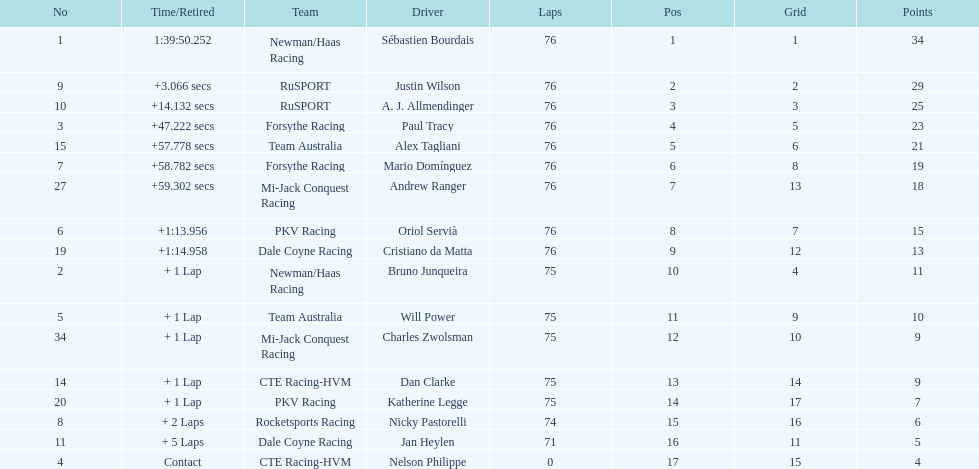Could you parse the entire table as a dict? {'header': ['No', 'Time/Retired', 'Team', 'Driver', 'Laps', 'Pos', 'Grid', 'Points'], 'rows': [['1', '1:39:50.252', 'Newman/Haas Racing', 'Sébastien Bourdais', '76', '1', '1', '34'], ['9', '+3.066 secs', 'RuSPORT', 'Justin Wilson', '76', '2', '2', '29'], ['10', '+14.132 secs', 'RuSPORT', 'A. J. Allmendinger', '76', '3', '3', '25'], ['3', '+47.222 secs', 'Forsythe Racing', 'Paul Tracy', '76', '4', '5', '23'], ['15', '+57.778 secs', 'Team Australia', 'Alex Tagliani', '76', '5', '6', '21'], ['7', '+58.782 secs', 'Forsythe Racing', 'Mario Domínguez', '76', '6', '8', '19'], ['27', '+59.302 secs', 'Mi-Jack Conquest Racing', 'Andrew Ranger', '76', '7', '13', '18'], ['6', '+1:13.956', 'PKV Racing', 'Oriol Servià', '76', '8', '7', '15'], ['19', '+1:14.958', 'Dale Coyne Racing', 'Cristiano da Matta', '76', '9', '12', '13'], ['2', '+ 1 Lap', 'Newman/Haas Racing', 'Bruno Junqueira', '75', '10', '4', '11'], ['5', '+ 1 Lap', 'Team Australia', 'Will Power', '75', '11', '9', '10'], ['34', '+ 1 Lap', 'Mi-Jack Conquest Racing', 'Charles Zwolsman', '75', '12', '10', '9'], ['14', '+ 1 Lap', 'CTE Racing-HVM', 'Dan Clarke', '75', '13', '14', '9'], ['20', '+ 1 Lap', 'PKV Racing', 'Katherine Legge', '75', '14', '17', '7'], ['8', '+ 2 Laps', 'Rocketsports Racing', 'Nicky Pastorelli', '74', '15', '16', '6'], ['11', '+ 5 Laps', 'Dale Coyne Racing', 'Jan Heylen', '71', '16', '11', '5'], ['4', 'Contact', 'CTE Racing-HVM', 'Nelson Philippe', '0', '17', '15', '4']]} Which driver accumulated the fewest points? Nelson Philippe. 